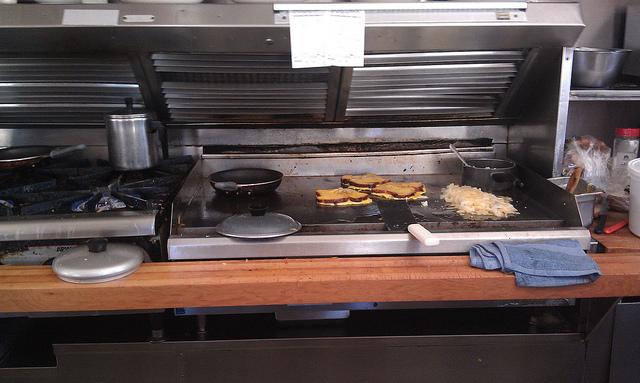Are any of the burners lit?
Concise answer only. Yes. How many sandwiches are on the grill?
Be succinct. 3. Is the cooktop gas?
Give a very brief answer. Yes. Is the spatula resting on the towel?
Give a very brief answer. No. What type of grill is being used?
Keep it brief. Electric. What is cooking?
Concise answer only. Sandwiches. What is the person cooking?
Short answer required. Grilled cheese. 